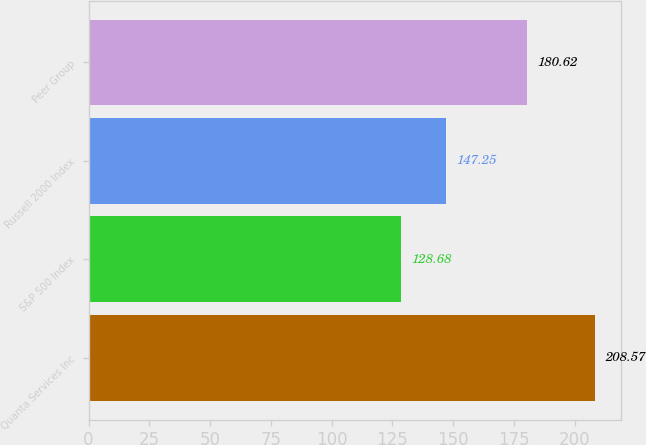<chart> <loc_0><loc_0><loc_500><loc_500><bar_chart><fcel>Quanta Services Inc<fcel>S&P 500 Index<fcel>Russell 2000 Index<fcel>Peer Group<nl><fcel>208.57<fcel>128.68<fcel>147.25<fcel>180.62<nl></chart> 